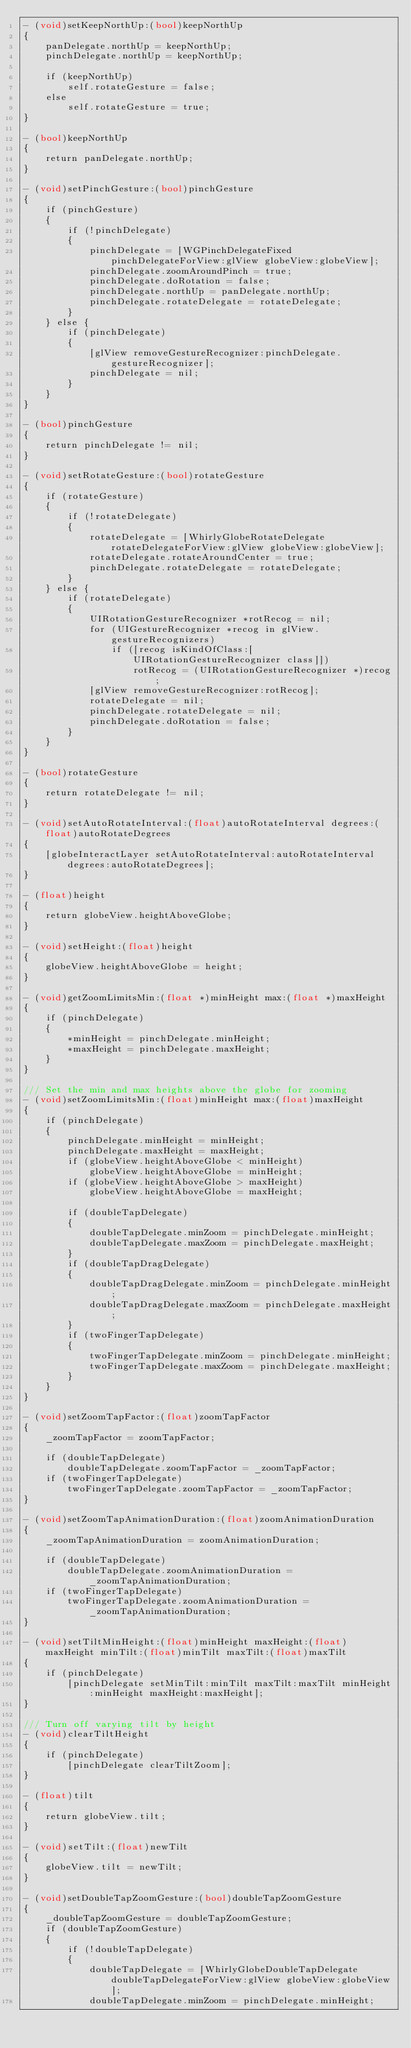<code> <loc_0><loc_0><loc_500><loc_500><_ObjectiveC_>- (void)setKeepNorthUp:(bool)keepNorthUp
{
    panDelegate.northUp = keepNorthUp;
    pinchDelegate.northUp = keepNorthUp;

    if (keepNorthUp)
        self.rotateGesture = false;
    else
        self.rotateGesture = true;
}

- (bool)keepNorthUp
{
    return panDelegate.northUp;
}

- (void)setPinchGesture:(bool)pinchGesture
{
    if (pinchGesture)
    {
        if (!pinchDelegate)
        {
            pinchDelegate = [WGPinchDelegateFixed pinchDelegateForView:glView globeView:globeView];
            pinchDelegate.zoomAroundPinch = true;
            pinchDelegate.doRotation = false;
            pinchDelegate.northUp = panDelegate.northUp;
            pinchDelegate.rotateDelegate = rotateDelegate;
        }
    } else {
        if (pinchDelegate)
        {
            [glView removeGestureRecognizer:pinchDelegate.gestureRecognizer];
            pinchDelegate = nil;
        }
    }
}

- (bool)pinchGesture
{
    return pinchDelegate != nil;
}

- (void)setRotateGesture:(bool)rotateGesture
{
    if (rotateGesture)
    {
        if (!rotateDelegate)
        {
            rotateDelegate = [WhirlyGlobeRotateDelegate rotateDelegateForView:glView globeView:globeView];
            rotateDelegate.rotateAroundCenter = true;
            pinchDelegate.rotateDelegate = rotateDelegate;
        }
    } else {
        if (rotateDelegate)
        {
            UIRotationGestureRecognizer *rotRecog = nil;
            for (UIGestureRecognizer *recog in glView.gestureRecognizers)
                if ([recog isKindOfClass:[UIRotationGestureRecognizer class]])
                    rotRecog = (UIRotationGestureRecognizer *)recog;
            [glView removeGestureRecognizer:rotRecog];
            rotateDelegate = nil;
            pinchDelegate.rotateDelegate = nil;
            pinchDelegate.doRotation = false;
        }
    }
}

- (bool)rotateGesture
{
    return rotateDelegate != nil;
}

- (void)setAutoRotateInterval:(float)autoRotateInterval degrees:(float)autoRotateDegrees
{
    [globeInteractLayer setAutoRotateInterval:autoRotateInterval degrees:autoRotateDegrees];
}

- (float)height
{
    return globeView.heightAboveGlobe;
}

- (void)setHeight:(float)height
{
    globeView.heightAboveGlobe = height;
}

- (void)getZoomLimitsMin:(float *)minHeight max:(float *)maxHeight
{
    if (pinchDelegate)
    {
        *minHeight = pinchDelegate.minHeight;
        *maxHeight = pinchDelegate.maxHeight;
    }
}

/// Set the min and max heights above the globe for zooming
- (void)setZoomLimitsMin:(float)minHeight max:(float)maxHeight
{
    if (pinchDelegate)
    {
        pinchDelegate.minHeight = minHeight;
        pinchDelegate.maxHeight = maxHeight;
        if (globeView.heightAboveGlobe < minHeight)
            globeView.heightAboveGlobe = minHeight;
        if (globeView.heightAboveGlobe > maxHeight)
            globeView.heightAboveGlobe = maxHeight;

        if (doubleTapDelegate)
        {
            doubleTapDelegate.minZoom = pinchDelegate.minHeight;
            doubleTapDelegate.maxZoom = pinchDelegate.maxHeight;
        }
        if (doubleTapDragDelegate)
        {
            doubleTapDragDelegate.minZoom = pinchDelegate.minHeight;
            doubleTapDragDelegate.maxZoom = pinchDelegate.maxHeight;
        }
        if (twoFingerTapDelegate)
        {
            twoFingerTapDelegate.minZoom = pinchDelegate.minHeight;
            twoFingerTapDelegate.maxZoom = pinchDelegate.maxHeight;
        }
    }
}

- (void)setZoomTapFactor:(float)zoomTapFactor
{
    _zoomTapFactor = zoomTapFactor;
    
    if (doubleTapDelegate)
        doubleTapDelegate.zoomTapFactor = _zoomTapFactor;
    if (twoFingerTapDelegate)
        twoFingerTapDelegate.zoomTapFactor = _zoomTapFactor;
}

- (void)setZoomTapAnimationDuration:(float)zoomAnimationDuration
{
    _zoomTapAnimationDuration = zoomAnimationDuration;
    
    if (doubleTapDelegate)
        doubleTapDelegate.zoomAnimationDuration = _zoomTapAnimationDuration;
    if (twoFingerTapDelegate)
        twoFingerTapDelegate.zoomAnimationDuration = _zoomTapAnimationDuration;
}

- (void)setTiltMinHeight:(float)minHeight maxHeight:(float)maxHeight minTilt:(float)minTilt maxTilt:(float)maxTilt
{
    if (pinchDelegate)
        [pinchDelegate setMinTilt:minTilt maxTilt:maxTilt minHeight:minHeight maxHeight:maxHeight];
}

/// Turn off varying tilt by height
- (void)clearTiltHeight
{
    if (pinchDelegate)
        [pinchDelegate clearTiltZoom];
}

- (float)tilt
{
    return globeView.tilt;
}

- (void)setTilt:(float)newTilt
{
    globeView.tilt = newTilt;
}

- (void)setDoubleTapZoomGesture:(bool)doubleTapZoomGesture
{
    _doubleTapZoomGesture = doubleTapZoomGesture;
    if (doubleTapZoomGesture)
    {
        if (!doubleTapDelegate)
        {
            doubleTapDelegate = [WhirlyGlobeDoubleTapDelegate doubleTapDelegateForView:glView globeView:globeView];
            doubleTapDelegate.minZoom = pinchDelegate.minHeight;</code> 